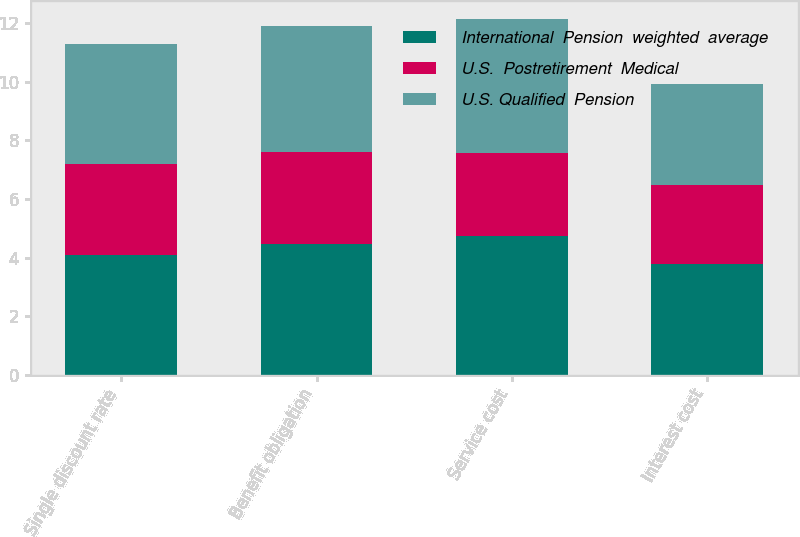Convert chart. <chart><loc_0><loc_0><loc_500><loc_500><stacked_bar_chart><ecel><fcel>Single discount rate<fcel>Benefit obligation<fcel>Service cost<fcel>Interest cost<nl><fcel>International  Pension  weighted  average<fcel>4.1<fcel>4.47<fcel>4.72<fcel>3.77<nl><fcel>U.S.  Postretirement  Medical<fcel>3.11<fcel>3.12<fcel>2.84<fcel>2.72<nl><fcel>U.S. Qualified  Pension<fcel>4.07<fcel>4.32<fcel>4.6<fcel>3.44<nl></chart> 